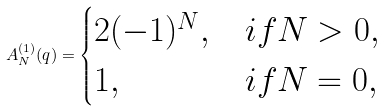Convert formula to latex. <formula><loc_0><loc_0><loc_500><loc_500>A _ { N } ^ { ( 1 ) } ( q ) = \begin{cases} 2 ( - 1 ) ^ { N } , & i f N > 0 , \\ 1 , & i f N = 0 , \end{cases}</formula> 